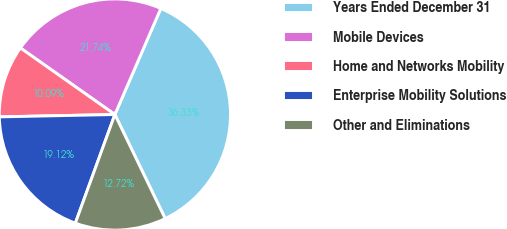Convert chart. <chart><loc_0><loc_0><loc_500><loc_500><pie_chart><fcel>Years Ended December 31<fcel>Mobile Devices<fcel>Home and Networks Mobility<fcel>Enterprise Mobility Solutions<fcel>Other and Eliminations<nl><fcel>36.33%<fcel>21.74%<fcel>10.09%<fcel>19.12%<fcel>12.72%<nl></chart> 